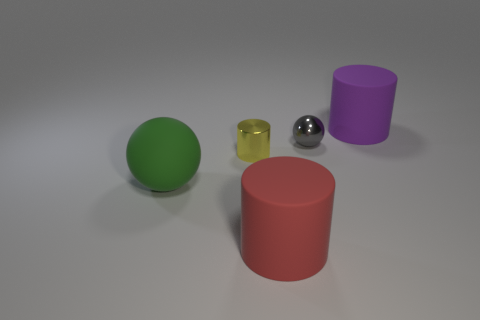What color is the matte object that is both left of the gray object and on the right side of the green ball?
Make the answer very short. Red. How many tiny things are on the right side of the tiny sphere?
Make the answer very short. 0. How many objects are gray metallic balls or cylinders in front of the tiny gray ball?
Your answer should be compact. 3. There is a tiny object that is right of the shiny cylinder; is there a big rubber object behind it?
Provide a short and direct response. Yes. What is the color of the small object that is in front of the tiny gray shiny ball?
Your answer should be very brief. Yellow. Are there the same number of big purple matte cylinders in front of the purple rubber cylinder and yellow spheres?
Your response must be concise. Yes. There is a object that is on the left side of the purple cylinder and right of the big red matte object; what is its shape?
Ensure brevity in your answer.  Sphere. What is the color of the small shiny thing that is the same shape as the large green matte thing?
Your response must be concise. Gray. Are there any other things that are the same color as the large ball?
Keep it short and to the point. No. There is a object behind the tiny thing that is right of the big red matte object that is in front of the gray metallic thing; what shape is it?
Your answer should be compact. Cylinder. 